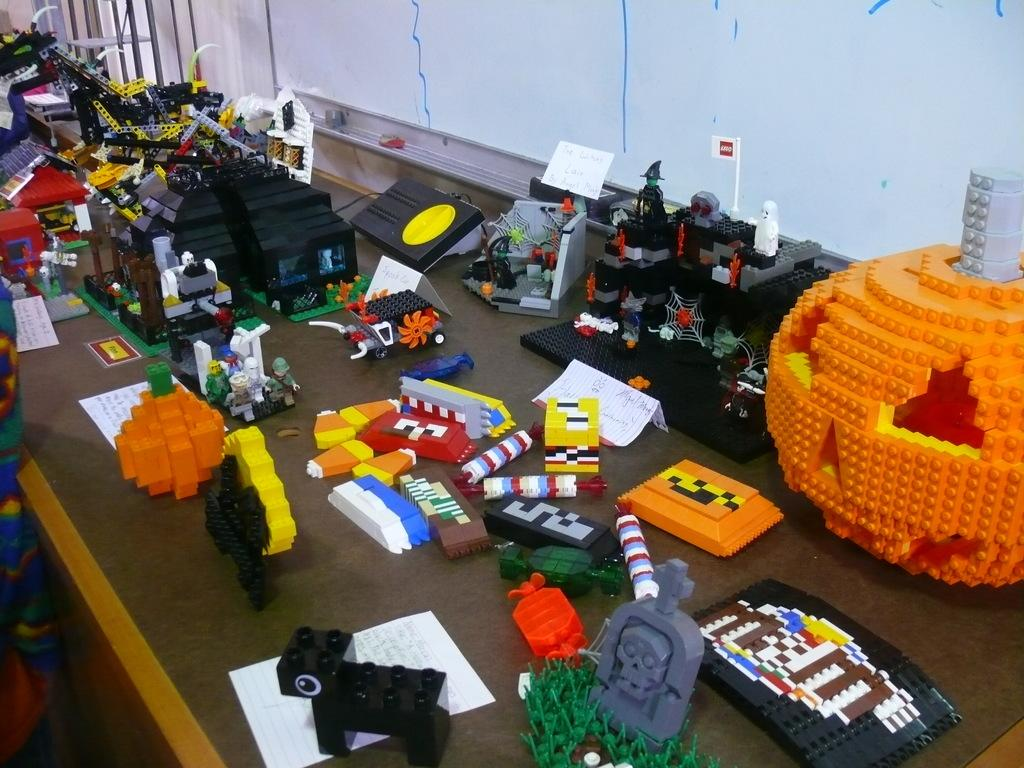What type of objects can be seen in the image? There are many toys, papers, and books on the table in the image. Where are the books located in the image? The books are on the table in the image. What can be seen in the background of the image? There is a wall in the background of the image. Is there a person visible in the image? Yes, there is a person on the left side of the image. What type of jail can be seen in the image? There is no jail present in the image. What type of prose is being written on the papers in the image? There is no indication of any writing on the papers in the image. Is there a railway visible in the image? There is no railway present in the image. 